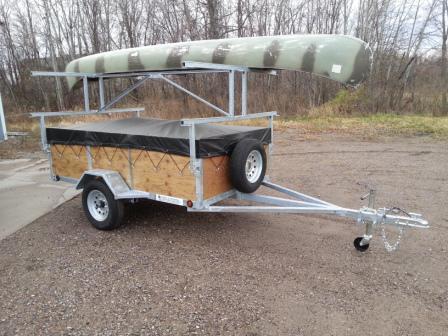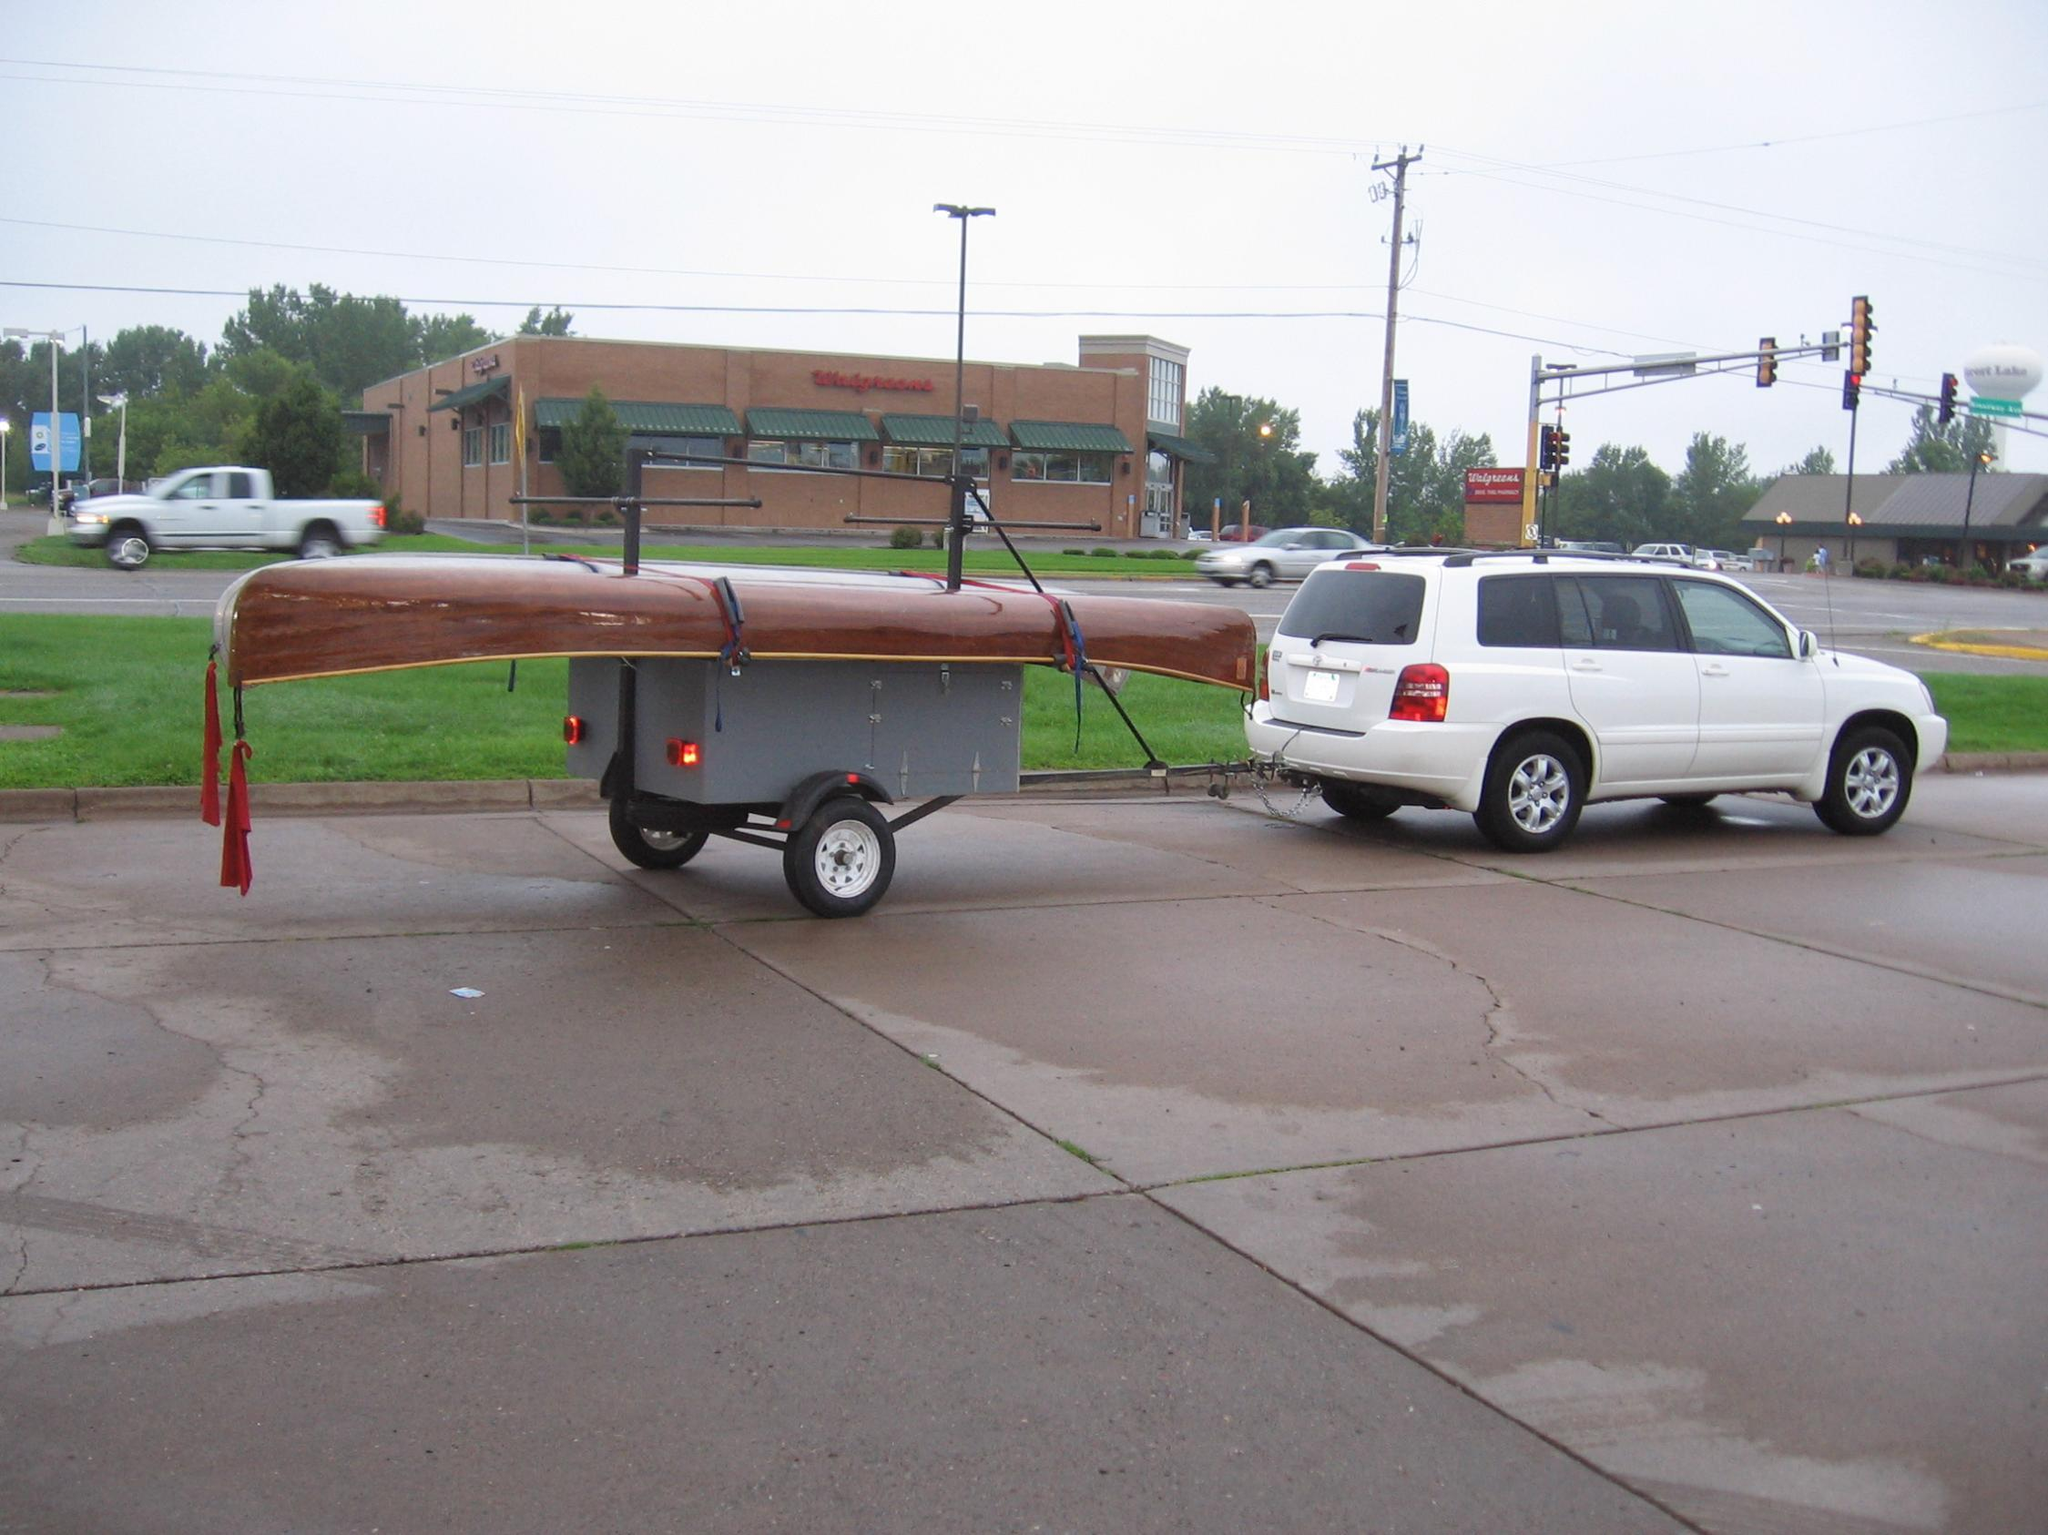The first image is the image on the left, the second image is the image on the right. Evaluate the accuracy of this statement regarding the images: "Two canoes of the same color are on a trailer.". Is it true? Answer yes or no. No. 